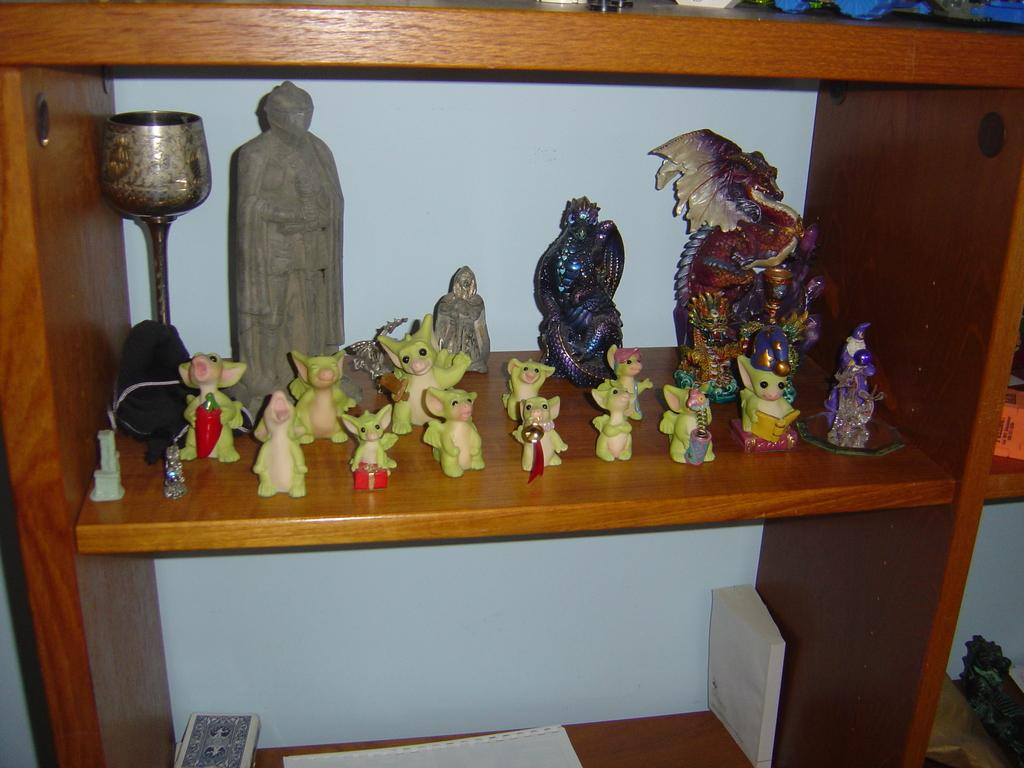What is inside the rack in the image? There are toys inside the rack. Can you describe the appearance of the toys? The toys are colorful. What color is the rock in the image? The rock is in brown color. What other items can be seen in the image besides the toys and rock? There are papers and books visible in the image. Where are the beds located in the image? There are no beds present in the image. Can you tell me how many chickens are visible in the image? There are no chickens present in the image. 